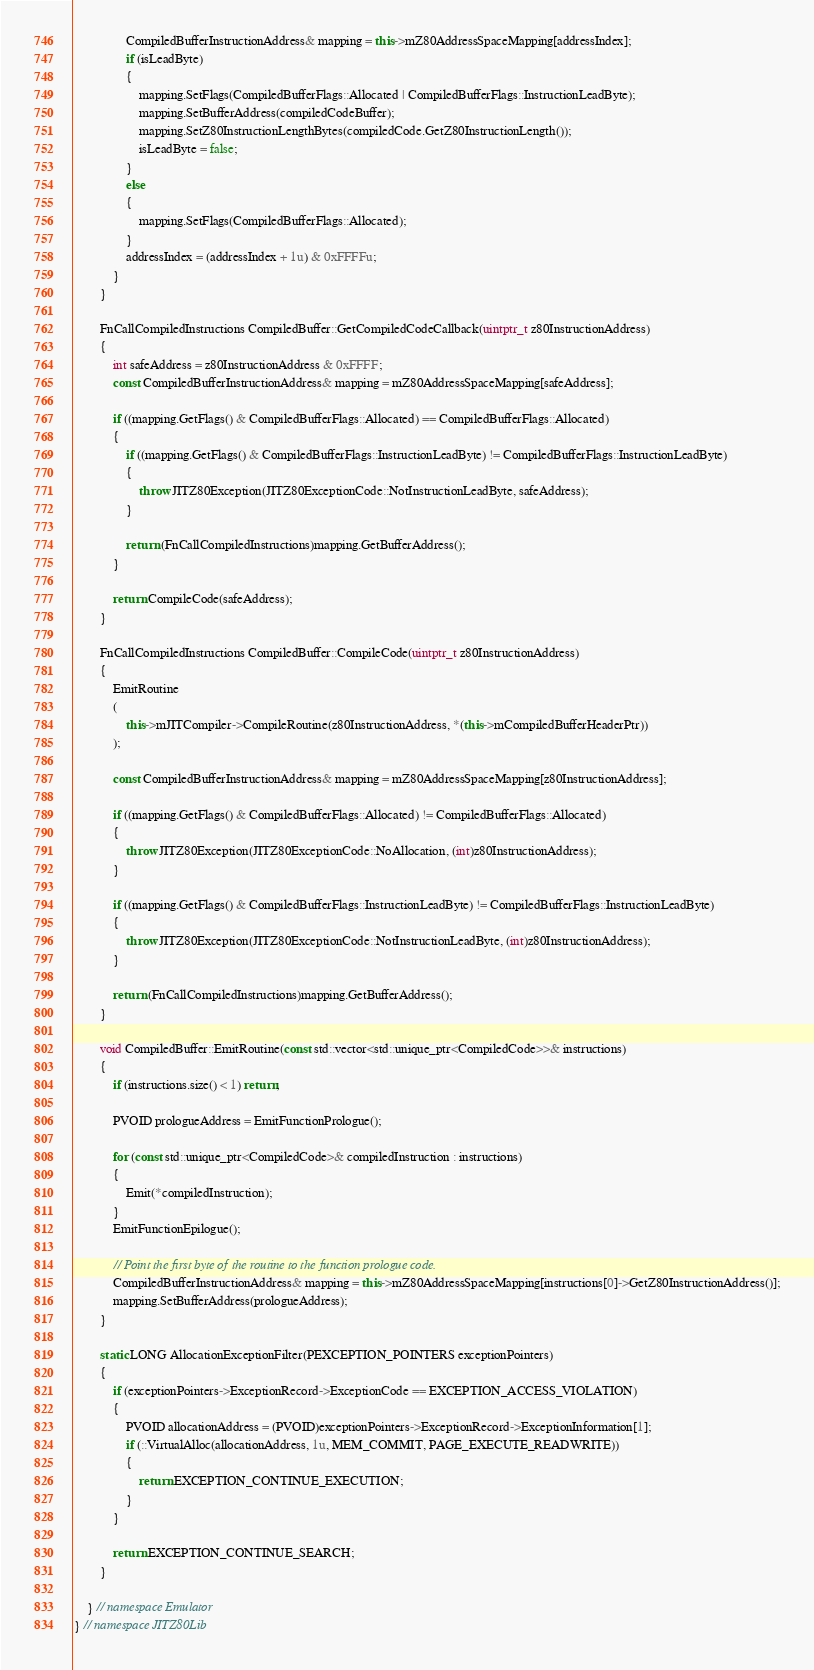Convert code to text. <code><loc_0><loc_0><loc_500><loc_500><_C++_>                CompiledBufferInstructionAddress& mapping = this->mZ80AddressSpaceMapping[addressIndex];
                if (isLeadByte)
                {
                    mapping.SetFlags(CompiledBufferFlags::Allocated | CompiledBufferFlags::InstructionLeadByte);
                    mapping.SetBufferAddress(compiledCodeBuffer);
                    mapping.SetZ80InstructionLengthBytes(compiledCode.GetZ80InstructionLength());
                    isLeadByte = false;
                }
                else
                {
                    mapping.SetFlags(CompiledBufferFlags::Allocated);
                }
                addressIndex = (addressIndex + 1u) & 0xFFFFu;
            }
        }

        FnCallCompiledInstructions CompiledBuffer::GetCompiledCodeCallback(uintptr_t z80InstructionAddress)
        {
            int safeAddress = z80InstructionAddress & 0xFFFF;
            const CompiledBufferInstructionAddress& mapping = mZ80AddressSpaceMapping[safeAddress];

            if ((mapping.GetFlags() & CompiledBufferFlags::Allocated) == CompiledBufferFlags::Allocated)
            {
                if ((mapping.GetFlags() & CompiledBufferFlags::InstructionLeadByte) != CompiledBufferFlags::InstructionLeadByte)
                {
                    throw JITZ80Exception(JITZ80ExceptionCode::NotInstructionLeadByte, safeAddress);
                }

                return (FnCallCompiledInstructions)mapping.GetBufferAddress();
            }

            return CompileCode(safeAddress);
        }

        FnCallCompiledInstructions CompiledBuffer::CompileCode(uintptr_t z80InstructionAddress)
        {
            EmitRoutine
            (
                this->mJITCompiler->CompileRoutine(z80InstructionAddress, *(this->mCompiledBufferHeaderPtr))
            );

            const CompiledBufferInstructionAddress& mapping = mZ80AddressSpaceMapping[z80InstructionAddress];

            if ((mapping.GetFlags() & CompiledBufferFlags::Allocated) != CompiledBufferFlags::Allocated)
            {
                throw JITZ80Exception(JITZ80ExceptionCode::NoAllocation, (int)z80InstructionAddress);
            }

            if ((mapping.GetFlags() & CompiledBufferFlags::InstructionLeadByte) != CompiledBufferFlags::InstructionLeadByte)
            {
                throw JITZ80Exception(JITZ80ExceptionCode::NotInstructionLeadByte, (int)z80InstructionAddress);
            }

            return (FnCallCompiledInstructions)mapping.GetBufferAddress();
        }

        void CompiledBuffer::EmitRoutine(const std::vector<std::unique_ptr<CompiledCode>>& instructions)
        {
            if (instructions.size() < 1) return;

            PVOID prologueAddress = EmitFunctionPrologue();

            for (const std::unique_ptr<CompiledCode>& compiledInstruction : instructions)
            {
                Emit(*compiledInstruction);
            }
            EmitFunctionEpilogue();

            // Point the first byte of the routine to the function prologue code.
            CompiledBufferInstructionAddress& mapping = this->mZ80AddressSpaceMapping[instructions[0]->GetZ80InstructionAddress()];
            mapping.SetBufferAddress(prologueAddress);
        }

        static LONG AllocationExceptionFilter(PEXCEPTION_POINTERS exceptionPointers)
        {
            if (exceptionPointers->ExceptionRecord->ExceptionCode == EXCEPTION_ACCESS_VIOLATION)
            {
                PVOID allocationAddress = (PVOID)exceptionPointers->ExceptionRecord->ExceptionInformation[1];
                if (::VirtualAlloc(allocationAddress, 1u, MEM_COMMIT, PAGE_EXECUTE_READWRITE))
                {
                    return EXCEPTION_CONTINUE_EXECUTION;
                }
            }

            return EXCEPTION_CONTINUE_SEARCH;
        }

    } // namespace Emulator
} // namespace JITZ80Lib
</code> 